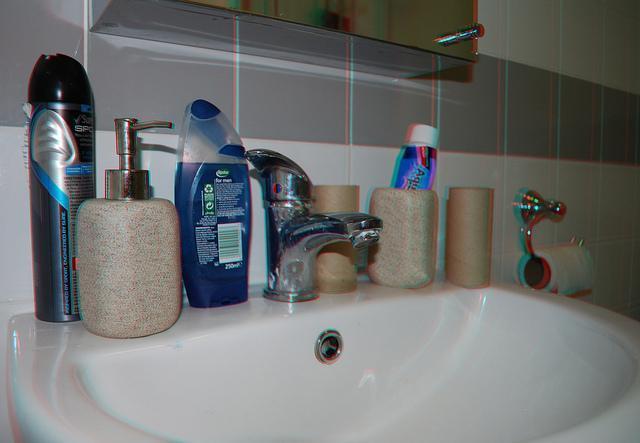How many bottles are there?
Give a very brief answer. 3. How many bikes are there?
Give a very brief answer. 0. 